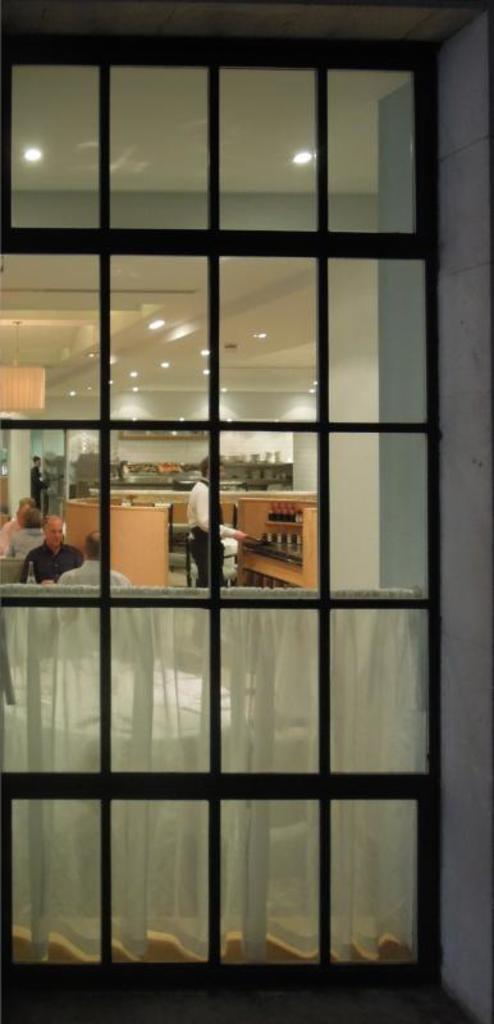How would you summarize this image in a sentence or two? In this image I can see the glass. Through the glass I can see the curtain and few people with different color dresses and these people are inside the building. I can see the lights in the top. 